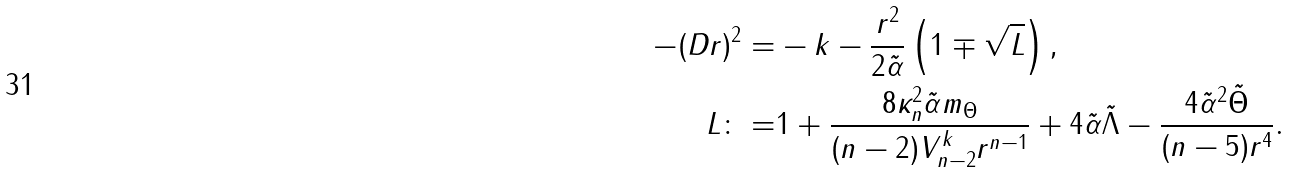Convert formula to latex. <formula><loc_0><loc_0><loc_500><loc_500>- ( D r ) ^ { 2 } = & - k - \frac { r ^ { 2 } } { 2 { \tilde { \alpha } } } \left ( 1 \mp \sqrt { L } \right ) , \\ L \colon = & 1 + \frac { 8 \kappa _ { n } ^ { 2 } { \tilde { \alpha } } m _ { \Theta } } { ( n - 2 ) V ^ { k } _ { n - 2 } r ^ { n - 1 } } + 4 { \tilde { \alpha } } { \tilde { \Lambda } } - \frac { 4 { \tilde { \alpha } } ^ { 2 } { \tilde { \Theta } } } { ( n - 5 ) r ^ { 4 } } .</formula> 